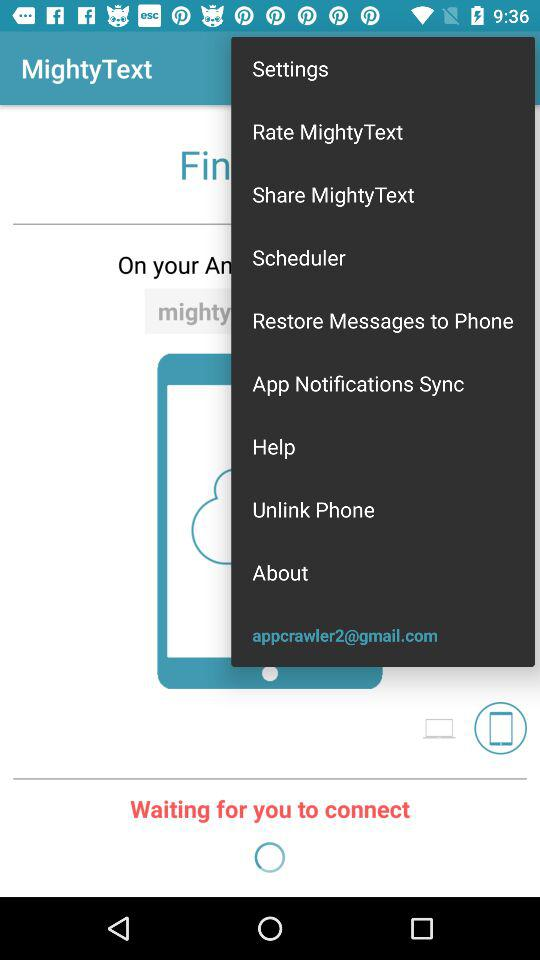What does "MightyText" application want to access? The application "MightyText" wants to access "SMS", "Contacts" and "Phone". 